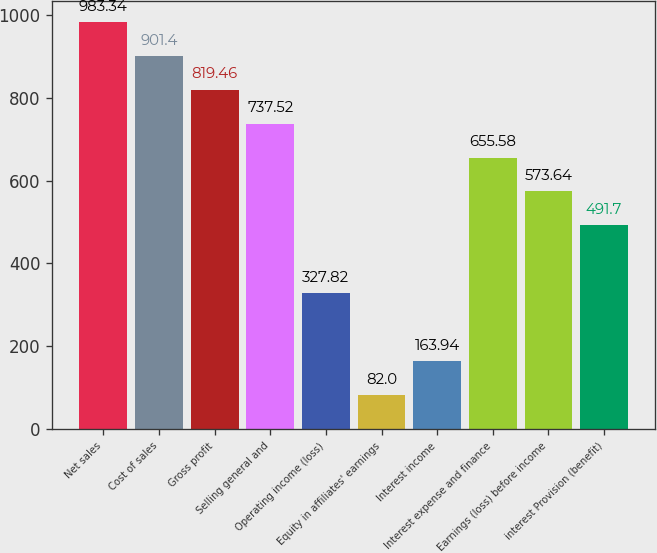Convert chart to OTSL. <chart><loc_0><loc_0><loc_500><loc_500><bar_chart><fcel>Net sales<fcel>Cost of sales<fcel>Gross profit<fcel>Selling general and<fcel>Operating income (loss)<fcel>Equity in affiliates' earnings<fcel>Interest income<fcel>Interest expense and finance<fcel>Earnings (loss) before income<fcel>interest Provision (benefit)<nl><fcel>983.34<fcel>901.4<fcel>819.46<fcel>737.52<fcel>327.82<fcel>82<fcel>163.94<fcel>655.58<fcel>573.64<fcel>491.7<nl></chart> 